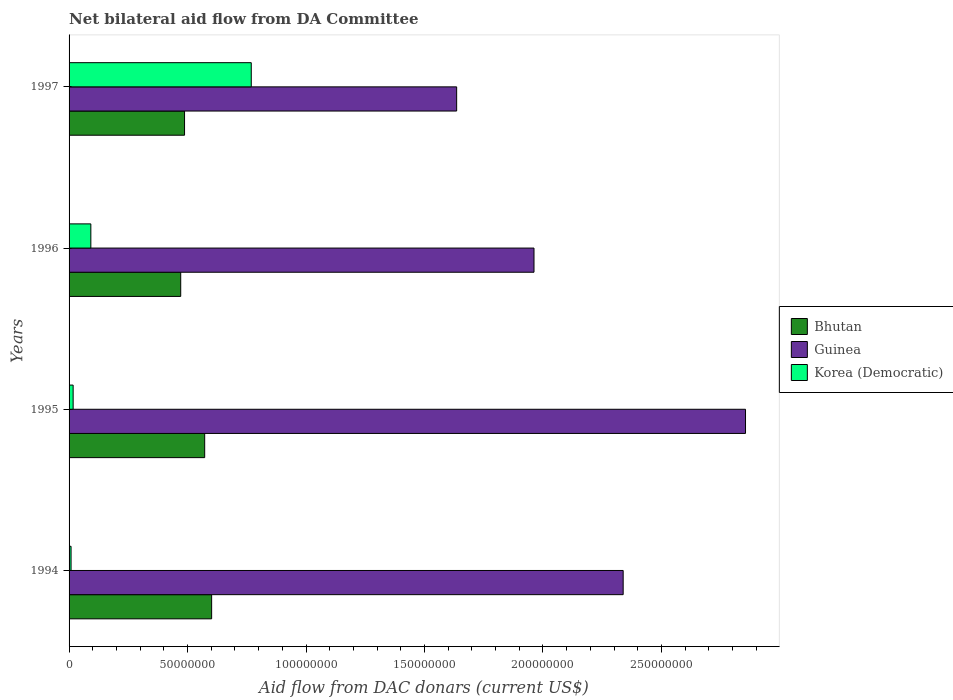How many different coloured bars are there?
Your answer should be very brief. 3. How many groups of bars are there?
Provide a succinct answer. 4. How many bars are there on the 1st tick from the top?
Ensure brevity in your answer.  3. How many bars are there on the 3rd tick from the bottom?
Your answer should be compact. 3. In how many cases, is the number of bars for a given year not equal to the number of legend labels?
Your answer should be very brief. 0. What is the aid flow in in Korea (Democratic) in 1995?
Your response must be concise. 1.72e+06. Across all years, what is the maximum aid flow in in Guinea?
Provide a succinct answer. 2.85e+08. Across all years, what is the minimum aid flow in in Bhutan?
Provide a short and direct response. 4.71e+07. In which year was the aid flow in in Guinea minimum?
Keep it short and to the point. 1997. What is the total aid flow in in Korea (Democratic) in the graph?
Make the answer very short. 8.86e+07. What is the difference between the aid flow in in Korea (Democratic) in 1994 and that in 1997?
Keep it short and to the point. -7.60e+07. What is the difference between the aid flow in in Korea (Democratic) in 1996 and the aid flow in in Guinea in 1995?
Keep it short and to the point. -2.76e+08. What is the average aid flow in in Korea (Democratic) per year?
Your response must be concise. 2.22e+07. In the year 1996, what is the difference between the aid flow in in Guinea and aid flow in in Korea (Democratic)?
Provide a short and direct response. 1.87e+08. What is the ratio of the aid flow in in Guinea in 1994 to that in 1997?
Make the answer very short. 1.43. What is the difference between the highest and the second highest aid flow in in Bhutan?
Make the answer very short. 2.94e+06. What is the difference between the highest and the lowest aid flow in in Korea (Democratic)?
Your answer should be very brief. 7.60e+07. In how many years, is the aid flow in in Guinea greater than the average aid flow in in Guinea taken over all years?
Your answer should be compact. 2. Is the sum of the aid flow in in Korea (Democratic) in 1996 and 1997 greater than the maximum aid flow in in Guinea across all years?
Your response must be concise. No. What does the 3rd bar from the top in 1997 represents?
Provide a succinct answer. Bhutan. What does the 2nd bar from the bottom in 1995 represents?
Your response must be concise. Guinea. How many bars are there?
Your response must be concise. 12. How many years are there in the graph?
Ensure brevity in your answer.  4. Are the values on the major ticks of X-axis written in scientific E-notation?
Make the answer very short. No. Does the graph contain grids?
Give a very brief answer. No. How many legend labels are there?
Your answer should be very brief. 3. How are the legend labels stacked?
Offer a terse response. Vertical. What is the title of the graph?
Keep it short and to the point. Net bilateral aid flow from DA Committee. What is the label or title of the X-axis?
Provide a short and direct response. Aid flow from DAC donars (current US$). What is the label or title of the Y-axis?
Give a very brief answer. Years. What is the Aid flow from DAC donars (current US$) of Bhutan in 1994?
Ensure brevity in your answer.  6.02e+07. What is the Aid flow from DAC donars (current US$) in Guinea in 1994?
Keep it short and to the point. 2.34e+08. What is the Aid flow from DAC donars (current US$) in Korea (Democratic) in 1994?
Ensure brevity in your answer.  8.40e+05. What is the Aid flow from DAC donars (current US$) in Bhutan in 1995?
Your answer should be compact. 5.72e+07. What is the Aid flow from DAC donars (current US$) of Guinea in 1995?
Provide a short and direct response. 2.85e+08. What is the Aid flow from DAC donars (current US$) of Korea (Democratic) in 1995?
Offer a very short reply. 1.72e+06. What is the Aid flow from DAC donars (current US$) in Bhutan in 1996?
Your answer should be very brief. 4.71e+07. What is the Aid flow from DAC donars (current US$) in Guinea in 1996?
Make the answer very short. 1.96e+08. What is the Aid flow from DAC donars (current US$) of Korea (Democratic) in 1996?
Provide a succinct answer. 9.19e+06. What is the Aid flow from DAC donars (current US$) of Bhutan in 1997?
Your answer should be compact. 4.87e+07. What is the Aid flow from DAC donars (current US$) in Guinea in 1997?
Offer a very short reply. 1.64e+08. What is the Aid flow from DAC donars (current US$) in Korea (Democratic) in 1997?
Offer a very short reply. 7.69e+07. Across all years, what is the maximum Aid flow from DAC donars (current US$) in Bhutan?
Ensure brevity in your answer.  6.02e+07. Across all years, what is the maximum Aid flow from DAC donars (current US$) in Guinea?
Your response must be concise. 2.85e+08. Across all years, what is the maximum Aid flow from DAC donars (current US$) of Korea (Democratic)?
Provide a succinct answer. 7.69e+07. Across all years, what is the minimum Aid flow from DAC donars (current US$) of Bhutan?
Provide a succinct answer. 4.71e+07. Across all years, what is the minimum Aid flow from DAC donars (current US$) in Guinea?
Keep it short and to the point. 1.64e+08. Across all years, what is the minimum Aid flow from DAC donars (current US$) of Korea (Democratic)?
Your response must be concise. 8.40e+05. What is the total Aid flow from DAC donars (current US$) in Bhutan in the graph?
Make the answer very short. 2.13e+08. What is the total Aid flow from DAC donars (current US$) in Guinea in the graph?
Offer a terse response. 8.79e+08. What is the total Aid flow from DAC donars (current US$) in Korea (Democratic) in the graph?
Offer a terse response. 8.86e+07. What is the difference between the Aid flow from DAC donars (current US$) in Bhutan in 1994 and that in 1995?
Offer a terse response. 2.94e+06. What is the difference between the Aid flow from DAC donars (current US$) in Guinea in 1994 and that in 1995?
Provide a succinct answer. -5.16e+07. What is the difference between the Aid flow from DAC donars (current US$) in Korea (Democratic) in 1994 and that in 1995?
Ensure brevity in your answer.  -8.80e+05. What is the difference between the Aid flow from DAC donars (current US$) of Bhutan in 1994 and that in 1996?
Your answer should be very brief. 1.30e+07. What is the difference between the Aid flow from DAC donars (current US$) in Guinea in 1994 and that in 1996?
Offer a terse response. 3.76e+07. What is the difference between the Aid flow from DAC donars (current US$) of Korea (Democratic) in 1994 and that in 1996?
Your response must be concise. -8.35e+06. What is the difference between the Aid flow from DAC donars (current US$) in Bhutan in 1994 and that in 1997?
Offer a terse response. 1.14e+07. What is the difference between the Aid flow from DAC donars (current US$) in Guinea in 1994 and that in 1997?
Offer a very short reply. 7.03e+07. What is the difference between the Aid flow from DAC donars (current US$) of Korea (Democratic) in 1994 and that in 1997?
Your answer should be compact. -7.60e+07. What is the difference between the Aid flow from DAC donars (current US$) in Bhutan in 1995 and that in 1996?
Offer a very short reply. 1.01e+07. What is the difference between the Aid flow from DAC donars (current US$) of Guinea in 1995 and that in 1996?
Provide a short and direct response. 8.93e+07. What is the difference between the Aid flow from DAC donars (current US$) in Korea (Democratic) in 1995 and that in 1996?
Your answer should be very brief. -7.47e+06. What is the difference between the Aid flow from DAC donars (current US$) of Bhutan in 1995 and that in 1997?
Provide a short and direct response. 8.50e+06. What is the difference between the Aid flow from DAC donars (current US$) in Guinea in 1995 and that in 1997?
Provide a succinct answer. 1.22e+08. What is the difference between the Aid flow from DAC donars (current US$) of Korea (Democratic) in 1995 and that in 1997?
Provide a short and direct response. -7.52e+07. What is the difference between the Aid flow from DAC donars (current US$) in Bhutan in 1996 and that in 1997?
Make the answer very short. -1.61e+06. What is the difference between the Aid flow from DAC donars (current US$) of Guinea in 1996 and that in 1997?
Provide a succinct answer. 3.26e+07. What is the difference between the Aid flow from DAC donars (current US$) in Korea (Democratic) in 1996 and that in 1997?
Offer a terse response. -6.77e+07. What is the difference between the Aid flow from DAC donars (current US$) in Bhutan in 1994 and the Aid flow from DAC donars (current US$) in Guinea in 1995?
Provide a short and direct response. -2.25e+08. What is the difference between the Aid flow from DAC donars (current US$) in Bhutan in 1994 and the Aid flow from DAC donars (current US$) in Korea (Democratic) in 1995?
Offer a very short reply. 5.84e+07. What is the difference between the Aid flow from DAC donars (current US$) of Guinea in 1994 and the Aid flow from DAC donars (current US$) of Korea (Democratic) in 1995?
Ensure brevity in your answer.  2.32e+08. What is the difference between the Aid flow from DAC donars (current US$) of Bhutan in 1994 and the Aid flow from DAC donars (current US$) of Guinea in 1996?
Offer a terse response. -1.36e+08. What is the difference between the Aid flow from DAC donars (current US$) of Bhutan in 1994 and the Aid flow from DAC donars (current US$) of Korea (Democratic) in 1996?
Provide a succinct answer. 5.10e+07. What is the difference between the Aid flow from DAC donars (current US$) of Guinea in 1994 and the Aid flow from DAC donars (current US$) of Korea (Democratic) in 1996?
Offer a very short reply. 2.25e+08. What is the difference between the Aid flow from DAC donars (current US$) in Bhutan in 1994 and the Aid flow from DAC donars (current US$) in Guinea in 1997?
Keep it short and to the point. -1.03e+08. What is the difference between the Aid flow from DAC donars (current US$) in Bhutan in 1994 and the Aid flow from DAC donars (current US$) in Korea (Democratic) in 1997?
Provide a succinct answer. -1.67e+07. What is the difference between the Aid flow from DAC donars (current US$) of Guinea in 1994 and the Aid flow from DAC donars (current US$) of Korea (Democratic) in 1997?
Offer a terse response. 1.57e+08. What is the difference between the Aid flow from DAC donars (current US$) of Bhutan in 1995 and the Aid flow from DAC donars (current US$) of Guinea in 1996?
Your answer should be compact. -1.39e+08. What is the difference between the Aid flow from DAC donars (current US$) in Bhutan in 1995 and the Aid flow from DAC donars (current US$) in Korea (Democratic) in 1996?
Your answer should be compact. 4.80e+07. What is the difference between the Aid flow from DAC donars (current US$) in Guinea in 1995 and the Aid flow from DAC donars (current US$) in Korea (Democratic) in 1996?
Provide a short and direct response. 2.76e+08. What is the difference between the Aid flow from DAC donars (current US$) of Bhutan in 1995 and the Aid flow from DAC donars (current US$) of Guinea in 1997?
Your answer should be very brief. -1.06e+08. What is the difference between the Aid flow from DAC donars (current US$) of Bhutan in 1995 and the Aid flow from DAC donars (current US$) of Korea (Democratic) in 1997?
Ensure brevity in your answer.  -1.97e+07. What is the difference between the Aid flow from DAC donars (current US$) of Guinea in 1995 and the Aid flow from DAC donars (current US$) of Korea (Democratic) in 1997?
Your answer should be very brief. 2.09e+08. What is the difference between the Aid flow from DAC donars (current US$) in Bhutan in 1996 and the Aid flow from DAC donars (current US$) in Guinea in 1997?
Your answer should be very brief. -1.16e+08. What is the difference between the Aid flow from DAC donars (current US$) in Bhutan in 1996 and the Aid flow from DAC donars (current US$) in Korea (Democratic) in 1997?
Your answer should be very brief. -2.98e+07. What is the difference between the Aid flow from DAC donars (current US$) in Guinea in 1996 and the Aid flow from DAC donars (current US$) in Korea (Democratic) in 1997?
Offer a terse response. 1.19e+08. What is the average Aid flow from DAC donars (current US$) of Bhutan per year?
Offer a very short reply. 5.33e+07. What is the average Aid flow from DAC donars (current US$) of Guinea per year?
Your answer should be compact. 2.20e+08. What is the average Aid flow from DAC donars (current US$) in Korea (Democratic) per year?
Your answer should be very brief. 2.22e+07. In the year 1994, what is the difference between the Aid flow from DAC donars (current US$) in Bhutan and Aid flow from DAC donars (current US$) in Guinea?
Provide a short and direct response. -1.74e+08. In the year 1994, what is the difference between the Aid flow from DAC donars (current US$) in Bhutan and Aid flow from DAC donars (current US$) in Korea (Democratic)?
Make the answer very short. 5.93e+07. In the year 1994, what is the difference between the Aid flow from DAC donars (current US$) in Guinea and Aid flow from DAC donars (current US$) in Korea (Democratic)?
Your answer should be compact. 2.33e+08. In the year 1995, what is the difference between the Aid flow from DAC donars (current US$) of Bhutan and Aid flow from DAC donars (current US$) of Guinea?
Provide a short and direct response. -2.28e+08. In the year 1995, what is the difference between the Aid flow from DAC donars (current US$) in Bhutan and Aid flow from DAC donars (current US$) in Korea (Democratic)?
Ensure brevity in your answer.  5.55e+07. In the year 1995, what is the difference between the Aid flow from DAC donars (current US$) of Guinea and Aid flow from DAC donars (current US$) of Korea (Democratic)?
Your response must be concise. 2.84e+08. In the year 1996, what is the difference between the Aid flow from DAC donars (current US$) of Bhutan and Aid flow from DAC donars (current US$) of Guinea?
Your answer should be very brief. -1.49e+08. In the year 1996, what is the difference between the Aid flow from DAC donars (current US$) of Bhutan and Aid flow from DAC donars (current US$) of Korea (Democratic)?
Your answer should be very brief. 3.79e+07. In the year 1996, what is the difference between the Aid flow from DAC donars (current US$) in Guinea and Aid flow from DAC donars (current US$) in Korea (Democratic)?
Offer a very short reply. 1.87e+08. In the year 1997, what is the difference between the Aid flow from DAC donars (current US$) in Bhutan and Aid flow from DAC donars (current US$) in Guinea?
Provide a succinct answer. -1.15e+08. In the year 1997, what is the difference between the Aid flow from DAC donars (current US$) of Bhutan and Aid flow from DAC donars (current US$) of Korea (Democratic)?
Your answer should be very brief. -2.82e+07. In the year 1997, what is the difference between the Aid flow from DAC donars (current US$) of Guinea and Aid flow from DAC donars (current US$) of Korea (Democratic)?
Keep it short and to the point. 8.67e+07. What is the ratio of the Aid flow from DAC donars (current US$) in Bhutan in 1994 to that in 1995?
Give a very brief answer. 1.05. What is the ratio of the Aid flow from DAC donars (current US$) in Guinea in 1994 to that in 1995?
Offer a very short reply. 0.82. What is the ratio of the Aid flow from DAC donars (current US$) of Korea (Democratic) in 1994 to that in 1995?
Provide a succinct answer. 0.49. What is the ratio of the Aid flow from DAC donars (current US$) in Bhutan in 1994 to that in 1996?
Your answer should be very brief. 1.28. What is the ratio of the Aid flow from DAC donars (current US$) of Guinea in 1994 to that in 1996?
Give a very brief answer. 1.19. What is the ratio of the Aid flow from DAC donars (current US$) in Korea (Democratic) in 1994 to that in 1996?
Offer a terse response. 0.09. What is the ratio of the Aid flow from DAC donars (current US$) in Bhutan in 1994 to that in 1997?
Your answer should be very brief. 1.23. What is the ratio of the Aid flow from DAC donars (current US$) of Guinea in 1994 to that in 1997?
Ensure brevity in your answer.  1.43. What is the ratio of the Aid flow from DAC donars (current US$) of Korea (Democratic) in 1994 to that in 1997?
Your answer should be very brief. 0.01. What is the ratio of the Aid flow from DAC donars (current US$) of Bhutan in 1995 to that in 1996?
Ensure brevity in your answer.  1.21. What is the ratio of the Aid flow from DAC donars (current US$) in Guinea in 1995 to that in 1996?
Give a very brief answer. 1.45. What is the ratio of the Aid flow from DAC donars (current US$) in Korea (Democratic) in 1995 to that in 1996?
Make the answer very short. 0.19. What is the ratio of the Aid flow from DAC donars (current US$) in Bhutan in 1995 to that in 1997?
Give a very brief answer. 1.17. What is the ratio of the Aid flow from DAC donars (current US$) in Guinea in 1995 to that in 1997?
Make the answer very short. 1.75. What is the ratio of the Aid flow from DAC donars (current US$) of Korea (Democratic) in 1995 to that in 1997?
Provide a succinct answer. 0.02. What is the ratio of the Aid flow from DAC donars (current US$) in Bhutan in 1996 to that in 1997?
Give a very brief answer. 0.97. What is the ratio of the Aid flow from DAC donars (current US$) in Guinea in 1996 to that in 1997?
Ensure brevity in your answer.  1.2. What is the ratio of the Aid flow from DAC donars (current US$) of Korea (Democratic) in 1996 to that in 1997?
Make the answer very short. 0.12. What is the difference between the highest and the second highest Aid flow from DAC donars (current US$) in Bhutan?
Provide a short and direct response. 2.94e+06. What is the difference between the highest and the second highest Aid flow from DAC donars (current US$) of Guinea?
Ensure brevity in your answer.  5.16e+07. What is the difference between the highest and the second highest Aid flow from DAC donars (current US$) in Korea (Democratic)?
Your answer should be very brief. 6.77e+07. What is the difference between the highest and the lowest Aid flow from DAC donars (current US$) of Bhutan?
Keep it short and to the point. 1.30e+07. What is the difference between the highest and the lowest Aid flow from DAC donars (current US$) in Guinea?
Offer a very short reply. 1.22e+08. What is the difference between the highest and the lowest Aid flow from DAC donars (current US$) in Korea (Democratic)?
Give a very brief answer. 7.60e+07. 